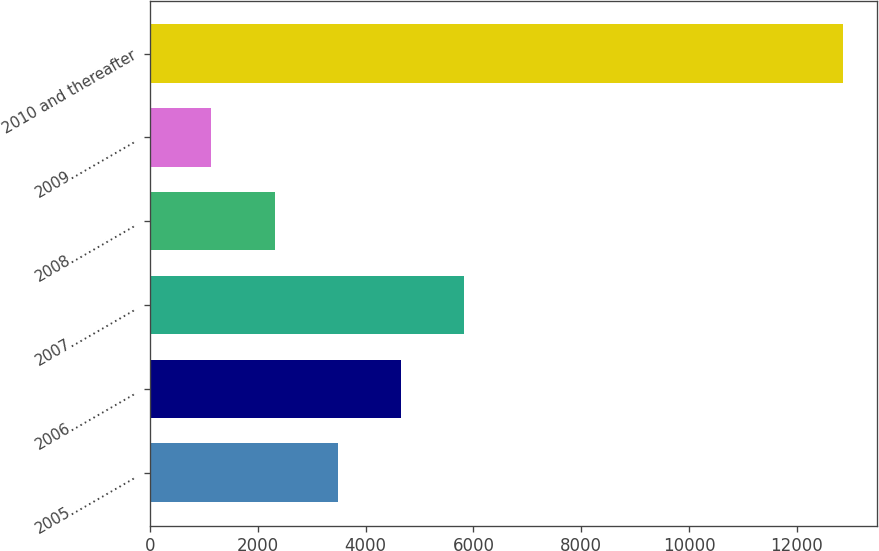Convert chart to OTSL. <chart><loc_0><loc_0><loc_500><loc_500><bar_chart><fcel>2005……………<fcel>2006……………<fcel>2007……………<fcel>2008……………<fcel>2009……………<fcel>2010 and thereafter<nl><fcel>3481<fcel>4652.5<fcel>5824<fcel>2309.5<fcel>1138<fcel>12853<nl></chart> 